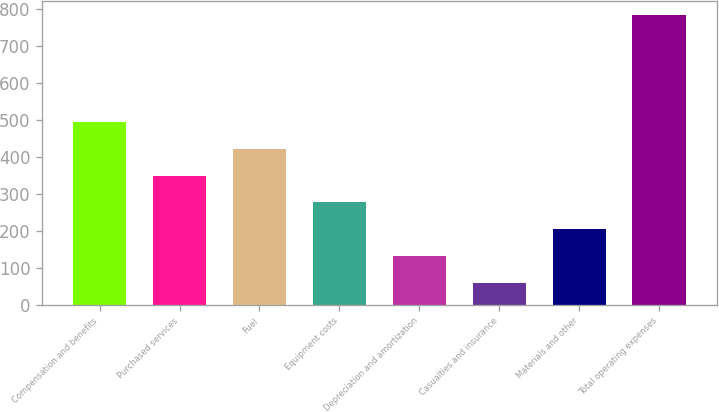Convert chart. <chart><loc_0><loc_0><loc_500><loc_500><bar_chart><fcel>Compensation and benefits<fcel>Purchased services<fcel>Fuel<fcel>Equipment costs<fcel>Depreciation and amortization<fcel>Casualties and insurance<fcel>Materials and other<fcel>Total operating expenses<nl><fcel>493.64<fcel>349.06<fcel>421.35<fcel>276.77<fcel>132.19<fcel>59.9<fcel>204.48<fcel>782.8<nl></chart> 